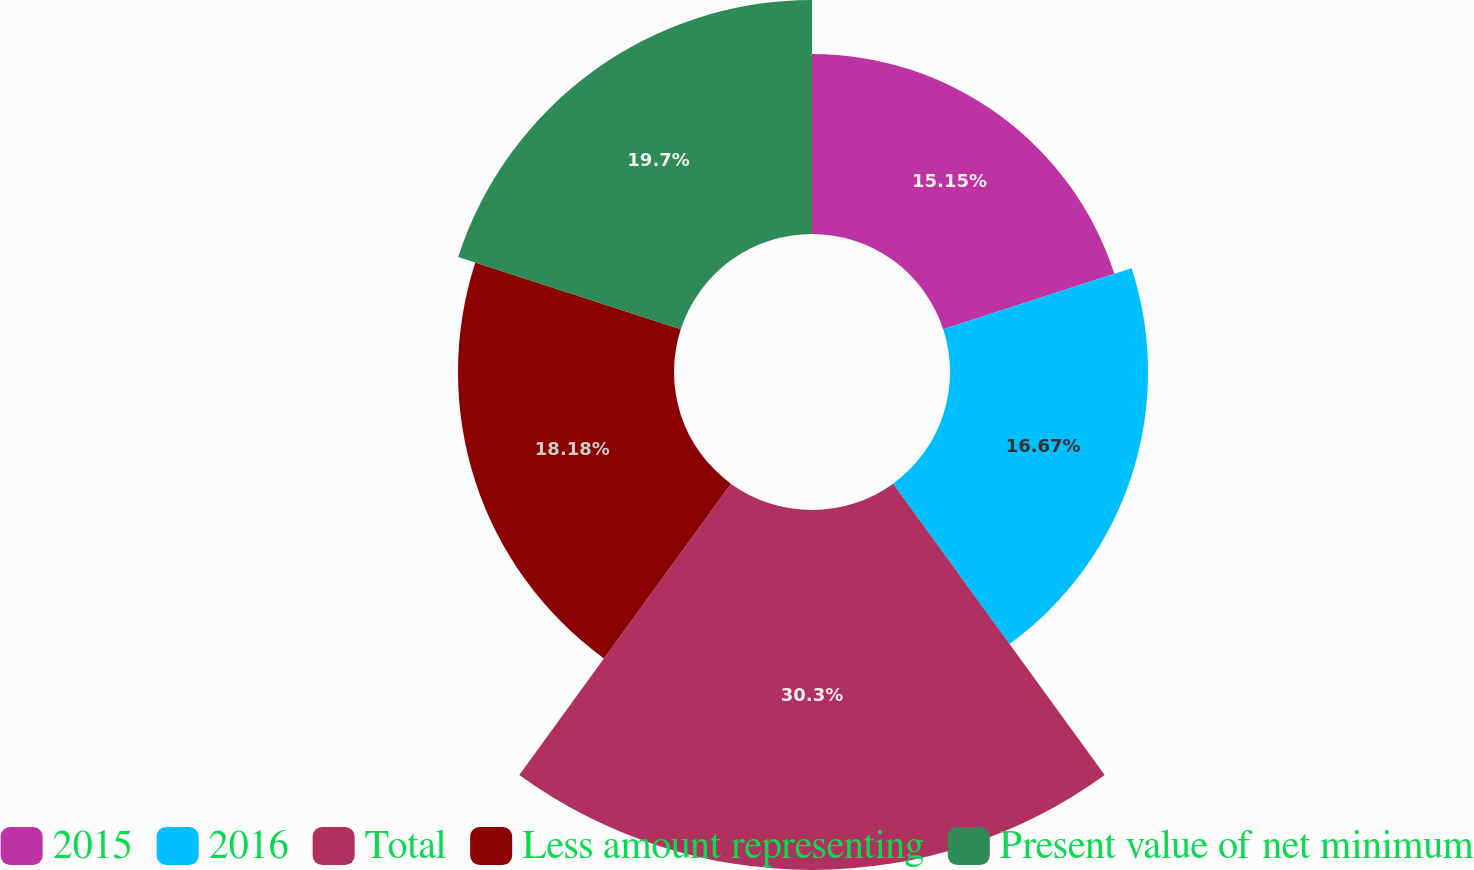Convert chart to OTSL. <chart><loc_0><loc_0><loc_500><loc_500><pie_chart><fcel>2015<fcel>2016<fcel>Total<fcel>Less amount representing<fcel>Present value of net minimum<nl><fcel>15.15%<fcel>16.67%<fcel>30.3%<fcel>18.18%<fcel>19.7%<nl></chart> 